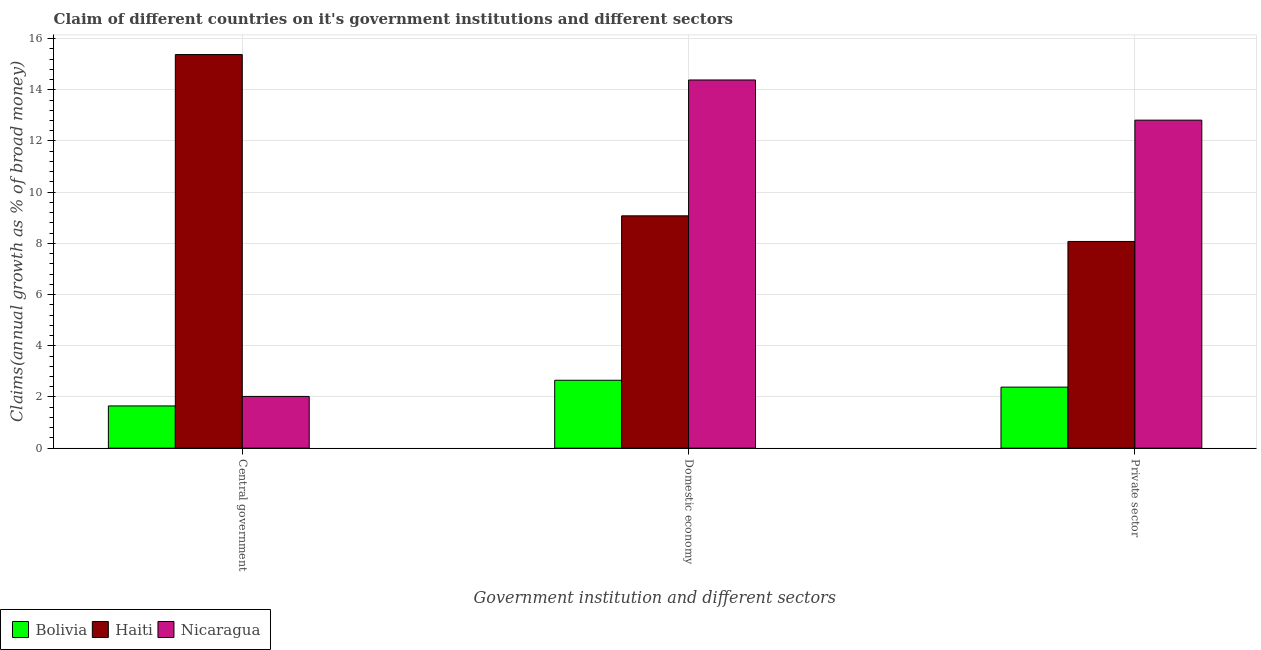How many different coloured bars are there?
Provide a succinct answer. 3. Are the number of bars on each tick of the X-axis equal?
Make the answer very short. Yes. How many bars are there on the 3rd tick from the left?
Your answer should be compact. 3. What is the label of the 1st group of bars from the left?
Your response must be concise. Central government. What is the percentage of claim on the central government in Haiti?
Give a very brief answer. 15.38. Across all countries, what is the maximum percentage of claim on the private sector?
Give a very brief answer. 12.81. Across all countries, what is the minimum percentage of claim on the central government?
Your answer should be compact. 1.65. In which country was the percentage of claim on the domestic economy maximum?
Make the answer very short. Nicaragua. What is the total percentage of claim on the private sector in the graph?
Provide a short and direct response. 23.27. What is the difference between the percentage of claim on the domestic economy in Haiti and that in Bolivia?
Give a very brief answer. 6.42. What is the difference between the percentage of claim on the domestic economy in Bolivia and the percentage of claim on the private sector in Nicaragua?
Give a very brief answer. -10.16. What is the average percentage of claim on the central government per country?
Offer a very short reply. 6.35. What is the difference between the percentage of claim on the private sector and percentage of claim on the central government in Haiti?
Make the answer very short. -7.3. What is the ratio of the percentage of claim on the central government in Haiti to that in Bolivia?
Provide a short and direct response. 9.32. Is the percentage of claim on the private sector in Nicaragua less than that in Bolivia?
Keep it short and to the point. No. What is the difference between the highest and the second highest percentage of claim on the domestic economy?
Your answer should be compact. 5.31. What is the difference between the highest and the lowest percentage of claim on the domestic economy?
Give a very brief answer. 11.73. Is the sum of the percentage of claim on the domestic economy in Haiti and Bolivia greater than the maximum percentage of claim on the central government across all countries?
Make the answer very short. No. What does the 1st bar from the left in Central government represents?
Offer a very short reply. Bolivia. Are all the bars in the graph horizontal?
Your answer should be very brief. No. How many countries are there in the graph?
Your answer should be very brief. 3. Does the graph contain any zero values?
Your answer should be compact. No. Does the graph contain grids?
Provide a short and direct response. Yes. What is the title of the graph?
Your answer should be compact. Claim of different countries on it's government institutions and different sectors. Does "High income" appear as one of the legend labels in the graph?
Your answer should be very brief. No. What is the label or title of the X-axis?
Make the answer very short. Government institution and different sectors. What is the label or title of the Y-axis?
Your answer should be very brief. Claims(annual growth as % of broad money). What is the Claims(annual growth as % of broad money) in Bolivia in Central government?
Your answer should be compact. 1.65. What is the Claims(annual growth as % of broad money) in Haiti in Central government?
Your answer should be compact. 15.38. What is the Claims(annual growth as % of broad money) of Nicaragua in Central government?
Provide a succinct answer. 2.02. What is the Claims(annual growth as % of broad money) of Bolivia in Domestic economy?
Give a very brief answer. 2.65. What is the Claims(annual growth as % of broad money) of Haiti in Domestic economy?
Give a very brief answer. 9.08. What is the Claims(annual growth as % of broad money) in Nicaragua in Domestic economy?
Your answer should be very brief. 14.38. What is the Claims(annual growth as % of broad money) of Bolivia in Private sector?
Ensure brevity in your answer.  2.38. What is the Claims(annual growth as % of broad money) of Haiti in Private sector?
Provide a short and direct response. 8.08. What is the Claims(annual growth as % of broad money) of Nicaragua in Private sector?
Your answer should be compact. 12.81. Across all Government institution and different sectors, what is the maximum Claims(annual growth as % of broad money) in Bolivia?
Give a very brief answer. 2.65. Across all Government institution and different sectors, what is the maximum Claims(annual growth as % of broad money) of Haiti?
Offer a terse response. 15.38. Across all Government institution and different sectors, what is the maximum Claims(annual growth as % of broad money) of Nicaragua?
Provide a succinct answer. 14.38. Across all Government institution and different sectors, what is the minimum Claims(annual growth as % of broad money) in Bolivia?
Make the answer very short. 1.65. Across all Government institution and different sectors, what is the minimum Claims(annual growth as % of broad money) of Haiti?
Offer a terse response. 8.08. Across all Government institution and different sectors, what is the minimum Claims(annual growth as % of broad money) of Nicaragua?
Provide a short and direct response. 2.02. What is the total Claims(annual growth as % of broad money) in Bolivia in the graph?
Give a very brief answer. 6.69. What is the total Claims(annual growth as % of broad money) in Haiti in the graph?
Your answer should be compact. 32.53. What is the total Claims(annual growth as % of broad money) of Nicaragua in the graph?
Offer a very short reply. 29.22. What is the difference between the Claims(annual growth as % of broad money) in Bolivia in Central government and that in Domestic economy?
Offer a very short reply. -1. What is the difference between the Claims(annual growth as % of broad money) of Haiti in Central government and that in Domestic economy?
Give a very brief answer. 6.3. What is the difference between the Claims(annual growth as % of broad money) of Nicaragua in Central government and that in Domestic economy?
Offer a very short reply. -12.36. What is the difference between the Claims(annual growth as % of broad money) in Bolivia in Central government and that in Private sector?
Ensure brevity in your answer.  -0.73. What is the difference between the Claims(annual growth as % of broad money) in Haiti in Central government and that in Private sector?
Your response must be concise. 7.3. What is the difference between the Claims(annual growth as % of broad money) in Nicaragua in Central government and that in Private sector?
Your answer should be compact. -10.79. What is the difference between the Claims(annual growth as % of broad money) in Bolivia in Domestic economy and that in Private sector?
Offer a terse response. 0.27. What is the difference between the Claims(annual growth as % of broad money) in Nicaragua in Domestic economy and that in Private sector?
Your answer should be very brief. 1.57. What is the difference between the Claims(annual growth as % of broad money) in Bolivia in Central government and the Claims(annual growth as % of broad money) in Haiti in Domestic economy?
Offer a terse response. -7.43. What is the difference between the Claims(annual growth as % of broad money) in Bolivia in Central government and the Claims(annual growth as % of broad money) in Nicaragua in Domestic economy?
Make the answer very short. -12.73. What is the difference between the Claims(annual growth as % of broad money) of Haiti in Central government and the Claims(annual growth as % of broad money) of Nicaragua in Domestic economy?
Provide a succinct answer. 0.99. What is the difference between the Claims(annual growth as % of broad money) of Bolivia in Central government and the Claims(annual growth as % of broad money) of Haiti in Private sector?
Ensure brevity in your answer.  -6.43. What is the difference between the Claims(annual growth as % of broad money) in Bolivia in Central government and the Claims(annual growth as % of broad money) in Nicaragua in Private sector?
Provide a succinct answer. -11.16. What is the difference between the Claims(annual growth as % of broad money) in Haiti in Central government and the Claims(annual growth as % of broad money) in Nicaragua in Private sector?
Your answer should be very brief. 2.56. What is the difference between the Claims(annual growth as % of broad money) of Bolivia in Domestic economy and the Claims(annual growth as % of broad money) of Haiti in Private sector?
Provide a short and direct response. -5.42. What is the difference between the Claims(annual growth as % of broad money) in Bolivia in Domestic economy and the Claims(annual growth as % of broad money) in Nicaragua in Private sector?
Keep it short and to the point. -10.16. What is the difference between the Claims(annual growth as % of broad money) of Haiti in Domestic economy and the Claims(annual growth as % of broad money) of Nicaragua in Private sector?
Keep it short and to the point. -3.74. What is the average Claims(annual growth as % of broad money) in Bolivia per Government institution and different sectors?
Your response must be concise. 2.23. What is the average Claims(annual growth as % of broad money) in Haiti per Government institution and different sectors?
Give a very brief answer. 10.84. What is the average Claims(annual growth as % of broad money) of Nicaragua per Government institution and different sectors?
Keep it short and to the point. 9.74. What is the difference between the Claims(annual growth as % of broad money) of Bolivia and Claims(annual growth as % of broad money) of Haiti in Central government?
Your response must be concise. -13.73. What is the difference between the Claims(annual growth as % of broad money) in Bolivia and Claims(annual growth as % of broad money) in Nicaragua in Central government?
Keep it short and to the point. -0.37. What is the difference between the Claims(annual growth as % of broad money) of Haiti and Claims(annual growth as % of broad money) of Nicaragua in Central government?
Keep it short and to the point. 13.36. What is the difference between the Claims(annual growth as % of broad money) in Bolivia and Claims(annual growth as % of broad money) in Haiti in Domestic economy?
Provide a short and direct response. -6.42. What is the difference between the Claims(annual growth as % of broad money) in Bolivia and Claims(annual growth as % of broad money) in Nicaragua in Domestic economy?
Your answer should be compact. -11.73. What is the difference between the Claims(annual growth as % of broad money) in Haiti and Claims(annual growth as % of broad money) in Nicaragua in Domestic economy?
Your response must be concise. -5.31. What is the difference between the Claims(annual growth as % of broad money) of Bolivia and Claims(annual growth as % of broad money) of Haiti in Private sector?
Keep it short and to the point. -5.69. What is the difference between the Claims(annual growth as % of broad money) of Bolivia and Claims(annual growth as % of broad money) of Nicaragua in Private sector?
Make the answer very short. -10.43. What is the difference between the Claims(annual growth as % of broad money) in Haiti and Claims(annual growth as % of broad money) in Nicaragua in Private sector?
Your response must be concise. -4.74. What is the ratio of the Claims(annual growth as % of broad money) of Bolivia in Central government to that in Domestic economy?
Your answer should be compact. 0.62. What is the ratio of the Claims(annual growth as % of broad money) of Haiti in Central government to that in Domestic economy?
Your answer should be compact. 1.69. What is the ratio of the Claims(annual growth as % of broad money) of Nicaragua in Central government to that in Domestic economy?
Provide a succinct answer. 0.14. What is the ratio of the Claims(annual growth as % of broad money) in Bolivia in Central government to that in Private sector?
Keep it short and to the point. 0.69. What is the ratio of the Claims(annual growth as % of broad money) in Haiti in Central government to that in Private sector?
Your response must be concise. 1.9. What is the ratio of the Claims(annual growth as % of broad money) of Nicaragua in Central government to that in Private sector?
Provide a succinct answer. 0.16. What is the ratio of the Claims(annual growth as % of broad money) of Bolivia in Domestic economy to that in Private sector?
Your answer should be very brief. 1.11. What is the ratio of the Claims(annual growth as % of broad money) of Haiti in Domestic economy to that in Private sector?
Provide a succinct answer. 1.12. What is the ratio of the Claims(annual growth as % of broad money) of Nicaragua in Domestic economy to that in Private sector?
Give a very brief answer. 1.12. What is the difference between the highest and the second highest Claims(annual growth as % of broad money) of Bolivia?
Your response must be concise. 0.27. What is the difference between the highest and the second highest Claims(annual growth as % of broad money) in Haiti?
Keep it short and to the point. 6.3. What is the difference between the highest and the second highest Claims(annual growth as % of broad money) of Nicaragua?
Provide a short and direct response. 1.57. What is the difference between the highest and the lowest Claims(annual growth as % of broad money) of Haiti?
Your answer should be compact. 7.3. What is the difference between the highest and the lowest Claims(annual growth as % of broad money) of Nicaragua?
Your response must be concise. 12.36. 